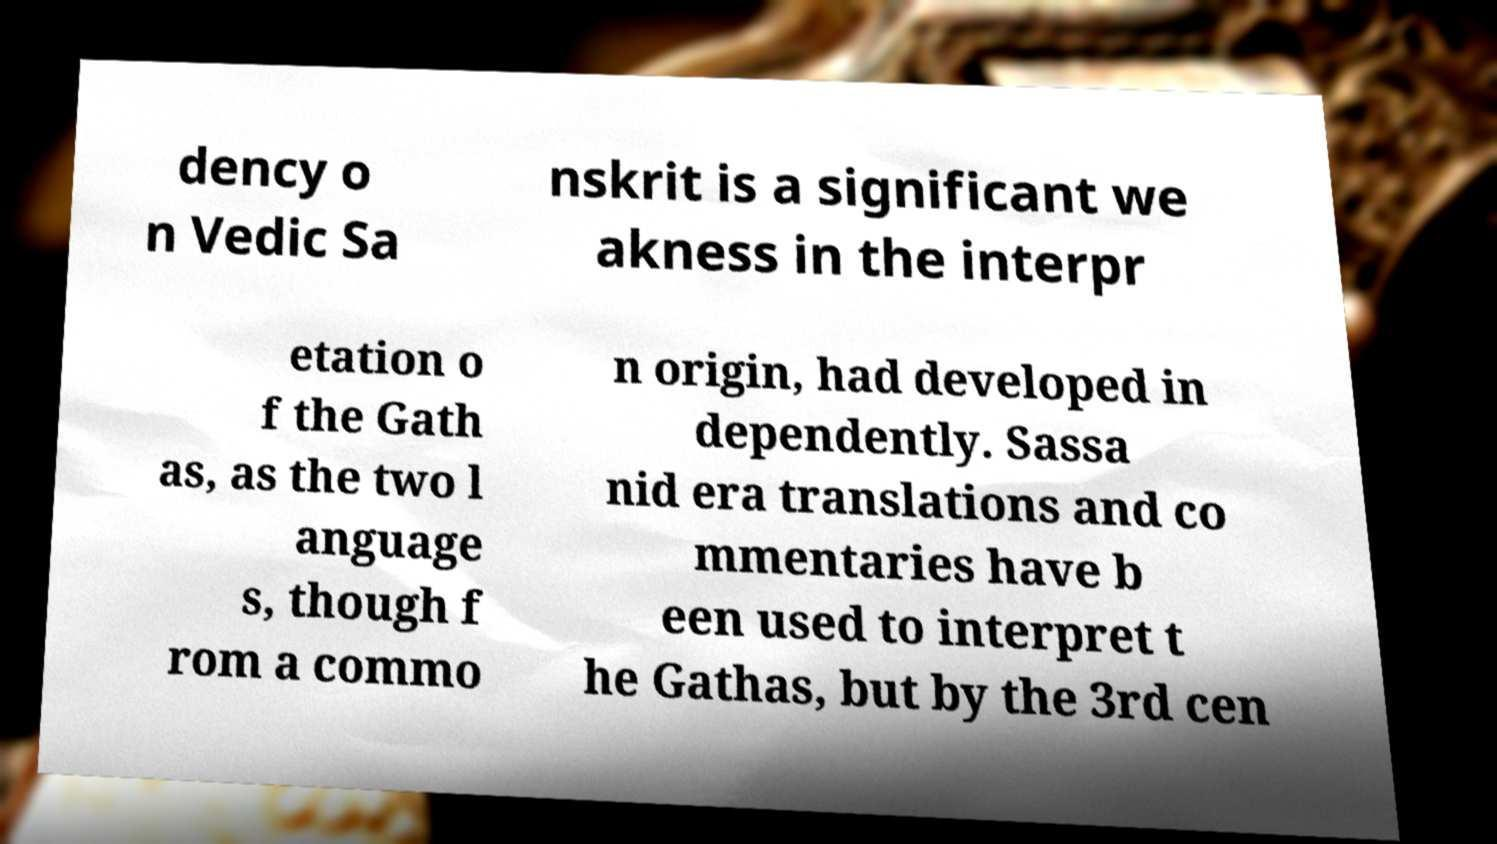What messages or text are displayed in this image? I need them in a readable, typed format. dency o n Vedic Sa nskrit is a significant we akness in the interpr etation o f the Gath as, as the two l anguage s, though f rom a commo n origin, had developed in dependently. Sassa nid era translations and co mmentaries have b een used to interpret t he Gathas, but by the 3rd cen 